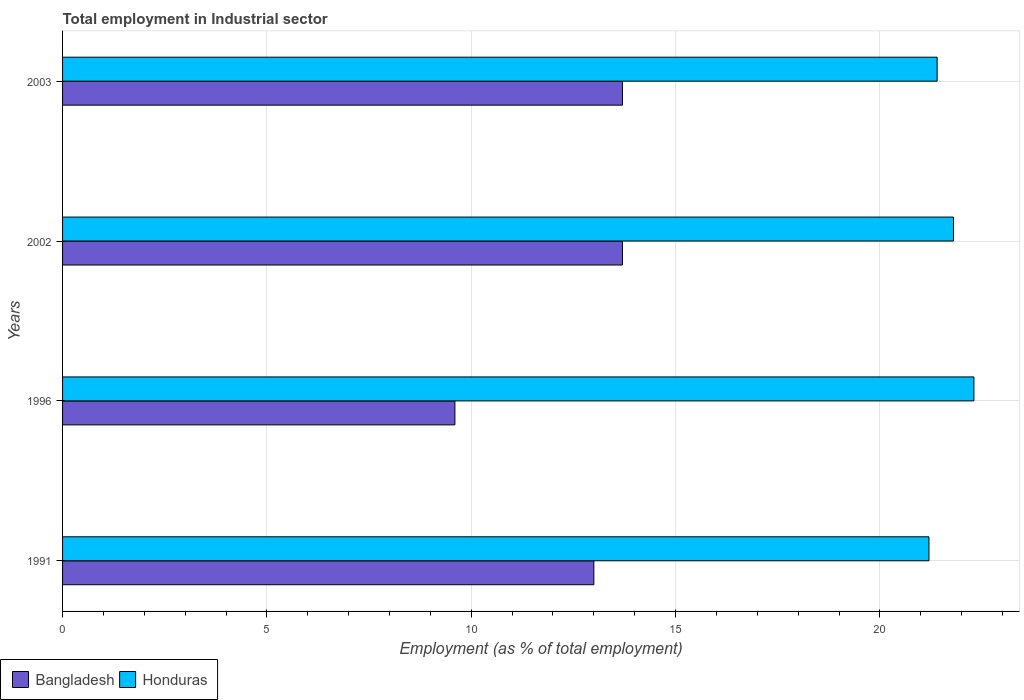Are the number of bars on each tick of the Y-axis equal?
Keep it short and to the point. Yes. How many bars are there on the 1st tick from the bottom?
Your answer should be compact. 2. What is the employment in industrial sector in Bangladesh in 2003?
Provide a succinct answer. 13.7. Across all years, what is the maximum employment in industrial sector in Honduras?
Your answer should be very brief. 22.3. Across all years, what is the minimum employment in industrial sector in Honduras?
Make the answer very short. 21.2. In which year was the employment in industrial sector in Bangladesh maximum?
Provide a succinct answer. 2002. In which year was the employment in industrial sector in Bangladesh minimum?
Keep it short and to the point. 1996. What is the total employment in industrial sector in Bangladesh in the graph?
Your answer should be compact. 50. What is the difference between the employment in industrial sector in Bangladesh in 1991 and that in 1996?
Your answer should be very brief. 3.4. What is the difference between the employment in industrial sector in Honduras in 2003 and the employment in industrial sector in Bangladesh in 2002?
Offer a very short reply. 7.7. What is the average employment in industrial sector in Honduras per year?
Provide a short and direct response. 21.67. In the year 2003, what is the difference between the employment in industrial sector in Honduras and employment in industrial sector in Bangladesh?
Your answer should be very brief. 7.7. In how many years, is the employment in industrial sector in Bangladesh greater than 12 %?
Make the answer very short. 3. What is the ratio of the employment in industrial sector in Honduras in 2002 to that in 2003?
Offer a terse response. 1.02. Is the difference between the employment in industrial sector in Honduras in 2002 and 2003 greater than the difference between the employment in industrial sector in Bangladesh in 2002 and 2003?
Keep it short and to the point. Yes. What is the difference between the highest and the second highest employment in industrial sector in Honduras?
Your response must be concise. 0.5. What is the difference between the highest and the lowest employment in industrial sector in Bangladesh?
Provide a short and direct response. 4.1. What does the 2nd bar from the top in 2003 represents?
Provide a short and direct response. Bangladesh. What does the 2nd bar from the bottom in 2003 represents?
Make the answer very short. Honduras. How many bars are there?
Your answer should be compact. 8. How many years are there in the graph?
Provide a succinct answer. 4. Are the values on the major ticks of X-axis written in scientific E-notation?
Provide a succinct answer. No. Does the graph contain any zero values?
Make the answer very short. No. Where does the legend appear in the graph?
Provide a short and direct response. Bottom left. How many legend labels are there?
Your response must be concise. 2. What is the title of the graph?
Make the answer very short. Total employment in Industrial sector. What is the label or title of the X-axis?
Make the answer very short. Employment (as % of total employment). What is the Employment (as % of total employment) in Honduras in 1991?
Ensure brevity in your answer.  21.2. What is the Employment (as % of total employment) of Bangladesh in 1996?
Offer a very short reply. 9.6. What is the Employment (as % of total employment) of Honduras in 1996?
Your answer should be compact. 22.3. What is the Employment (as % of total employment) in Bangladesh in 2002?
Your response must be concise. 13.7. What is the Employment (as % of total employment) in Honduras in 2002?
Your answer should be compact. 21.8. What is the Employment (as % of total employment) of Bangladesh in 2003?
Your answer should be compact. 13.7. What is the Employment (as % of total employment) of Honduras in 2003?
Ensure brevity in your answer.  21.4. Across all years, what is the maximum Employment (as % of total employment) of Bangladesh?
Your response must be concise. 13.7. Across all years, what is the maximum Employment (as % of total employment) of Honduras?
Ensure brevity in your answer.  22.3. Across all years, what is the minimum Employment (as % of total employment) in Bangladesh?
Your answer should be compact. 9.6. Across all years, what is the minimum Employment (as % of total employment) of Honduras?
Your answer should be compact. 21.2. What is the total Employment (as % of total employment) in Bangladesh in the graph?
Your answer should be very brief. 50. What is the total Employment (as % of total employment) in Honduras in the graph?
Your answer should be compact. 86.7. What is the difference between the Employment (as % of total employment) of Bangladesh in 1991 and that in 2002?
Your answer should be compact. -0.7. What is the difference between the Employment (as % of total employment) in Honduras in 1991 and that in 2002?
Offer a terse response. -0.6. What is the difference between the Employment (as % of total employment) of Bangladesh in 1991 and that in 2003?
Offer a terse response. -0.7. What is the difference between the Employment (as % of total employment) in Bangladesh in 1996 and that in 2002?
Offer a very short reply. -4.1. What is the difference between the Employment (as % of total employment) of Honduras in 1996 and that in 2002?
Provide a succinct answer. 0.5. What is the difference between the Employment (as % of total employment) of Honduras in 1996 and that in 2003?
Give a very brief answer. 0.9. What is the difference between the Employment (as % of total employment) of Bangladesh in 2002 and that in 2003?
Provide a succinct answer. 0. What is the difference between the Employment (as % of total employment) in Bangladesh in 1991 and the Employment (as % of total employment) in Honduras in 1996?
Your answer should be very brief. -9.3. What is the difference between the Employment (as % of total employment) of Bangladesh in 1991 and the Employment (as % of total employment) of Honduras in 2002?
Provide a short and direct response. -8.8. What is the difference between the Employment (as % of total employment) of Bangladesh in 1996 and the Employment (as % of total employment) of Honduras in 2002?
Provide a succinct answer. -12.2. What is the difference between the Employment (as % of total employment) in Bangladesh in 1996 and the Employment (as % of total employment) in Honduras in 2003?
Keep it short and to the point. -11.8. What is the difference between the Employment (as % of total employment) in Bangladesh in 2002 and the Employment (as % of total employment) in Honduras in 2003?
Give a very brief answer. -7.7. What is the average Employment (as % of total employment) of Bangladesh per year?
Your answer should be very brief. 12.5. What is the average Employment (as % of total employment) in Honduras per year?
Provide a succinct answer. 21.68. What is the ratio of the Employment (as % of total employment) in Bangladesh in 1991 to that in 1996?
Your answer should be very brief. 1.35. What is the ratio of the Employment (as % of total employment) of Honduras in 1991 to that in 1996?
Give a very brief answer. 0.95. What is the ratio of the Employment (as % of total employment) of Bangladesh in 1991 to that in 2002?
Make the answer very short. 0.95. What is the ratio of the Employment (as % of total employment) in Honduras in 1991 to that in 2002?
Ensure brevity in your answer.  0.97. What is the ratio of the Employment (as % of total employment) of Bangladesh in 1991 to that in 2003?
Provide a succinct answer. 0.95. What is the ratio of the Employment (as % of total employment) of Honduras in 1991 to that in 2003?
Ensure brevity in your answer.  0.99. What is the ratio of the Employment (as % of total employment) in Bangladesh in 1996 to that in 2002?
Your answer should be compact. 0.7. What is the ratio of the Employment (as % of total employment) of Honduras in 1996 to that in 2002?
Provide a short and direct response. 1.02. What is the ratio of the Employment (as % of total employment) of Bangladesh in 1996 to that in 2003?
Offer a very short reply. 0.7. What is the ratio of the Employment (as % of total employment) in Honduras in 1996 to that in 2003?
Keep it short and to the point. 1.04. What is the ratio of the Employment (as % of total employment) in Bangladesh in 2002 to that in 2003?
Provide a succinct answer. 1. What is the ratio of the Employment (as % of total employment) in Honduras in 2002 to that in 2003?
Provide a succinct answer. 1.02. What is the difference between the highest and the second highest Employment (as % of total employment) of Honduras?
Ensure brevity in your answer.  0.5. What is the difference between the highest and the lowest Employment (as % of total employment) of Bangladesh?
Ensure brevity in your answer.  4.1. What is the difference between the highest and the lowest Employment (as % of total employment) in Honduras?
Keep it short and to the point. 1.1. 